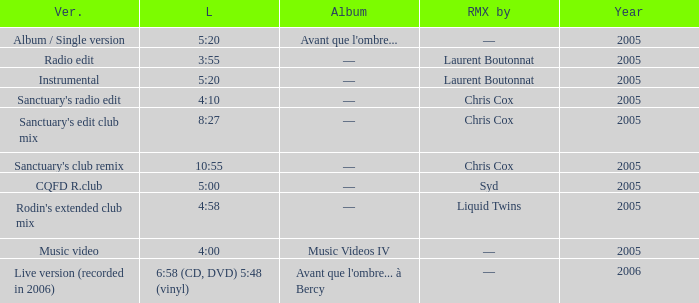What is the version shown for the Length of 4:58? Rodin's extended club mix. 